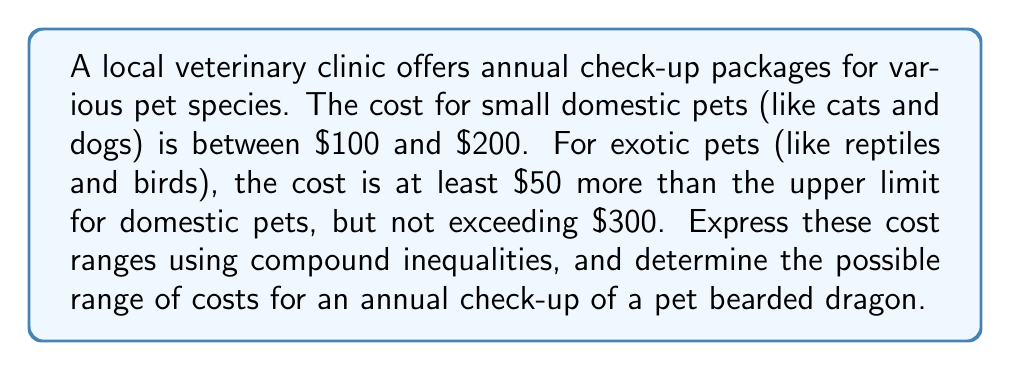Provide a solution to this math problem. Let's approach this step-by-step:

1. Express the cost range for small domestic pets:
   $100 \leq x \leq 200$, where $x$ is the cost in dollars.

2. For exotic pets, we need to consider two conditions:
   a) At least $50 more than the upper limit for domestic pets:
      $x > 200 + 50$ or $x > 250$
   b) Not exceeding $300:
      $x \leq 300$

3. Combine these conditions for exotic pets:
   $250 < x \leq 300$

4. A bearded dragon is an exotic pet, so its annual check-up cost would fall within the range for exotic pets.

5. Therefore, the possible range of costs for an annual check-up of a pet bearded dragon can be expressed as:
   $250 < x \leq 300$

This inequality means that the cost will be more than $250 but not exceed $300.
Answer: $250 < x \leq 300$, where $x$ is the cost in dollars 